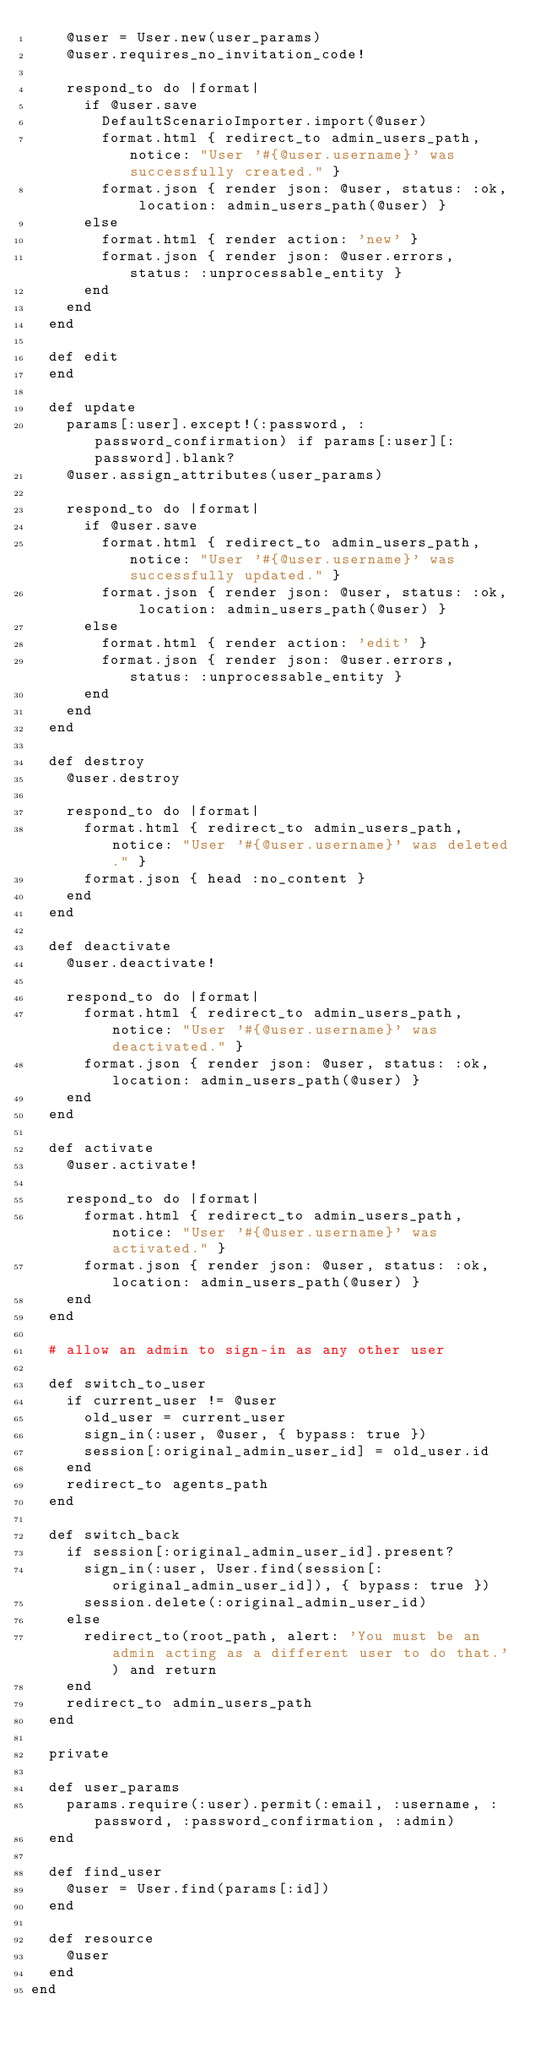<code> <loc_0><loc_0><loc_500><loc_500><_Ruby_>    @user = User.new(user_params)
    @user.requires_no_invitation_code!

    respond_to do |format|
      if @user.save
        DefaultScenarioImporter.import(@user)    
        format.html { redirect_to admin_users_path, notice: "User '#{@user.username}' was successfully created." }
        format.json { render json: @user, status: :ok, location: admin_users_path(@user) }
      else
        format.html { render action: 'new' }
        format.json { render json: @user.errors, status: :unprocessable_entity }
      end
    end
  end

  def edit
  end

  def update
    params[:user].except!(:password, :password_confirmation) if params[:user][:password].blank?
    @user.assign_attributes(user_params)

    respond_to do |format|
      if @user.save
        format.html { redirect_to admin_users_path, notice: "User '#{@user.username}' was successfully updated." }
        format.json { render json: @user, status: :ok, location: admin_users_path(@user) }
      else
        format.html { render action: 'edit' }
        format.json { render json: @user.errors, status: :unprocessable_entity }
      end
    end
  end

  def destroy
    @user.destroy

    respond_to do |format|
      format.html { redirect_to admin_users_path, notice: "User '#{@user.username}' was deleted." }
      format.json { head :no_content }
    end
  end

  def deactivate
    @user.deactivate!

    respond_to do |format|
      format.html { redirect_to admin_users_path, notice: "User '#{@user.username}' was deactivated." }
      format.json { render json: @user, status: :ok, location: admin_users_path(@user) }
    end
  end

  def activate
    @user.activate!

    respond_to do |format|
      format.html { redirect_to admin_users_path, notice: "User '#{@user.username}' was activated." }
      format.json { render json: @user, status: :ok, location: admin_users_path(@user) }
    end
  end

  # allow an admin to sign-in as any other user

  def switch_to_user
    if current_user != @user
      old_user = current_user
      sign_in(:user, @user, { bypass: true })
      session[:original_admin_user_id] = old_user.id
    end
    redirect_to agents_path
  end

  def switch_back
    if session[:original_admin_user_id].present?
      sign_in(:user, User.find(session[:original_admin_user_id]), { bypass: true })
      session.delete(:original_admin_user_id)
    else
      redirect_to(root_path, alert: 'You must be an admin acting as a different user to do that.') and return
    end
    redirect_to admin_users_path
  end

  private

  def user_params
    params.require(:user).permit(:email, :username, :password, :password_confirmation, :admin)
  end

  def find_user
    @user = User.find(params[:id])
  end

  def resource
    @user
  end
end
</code> 